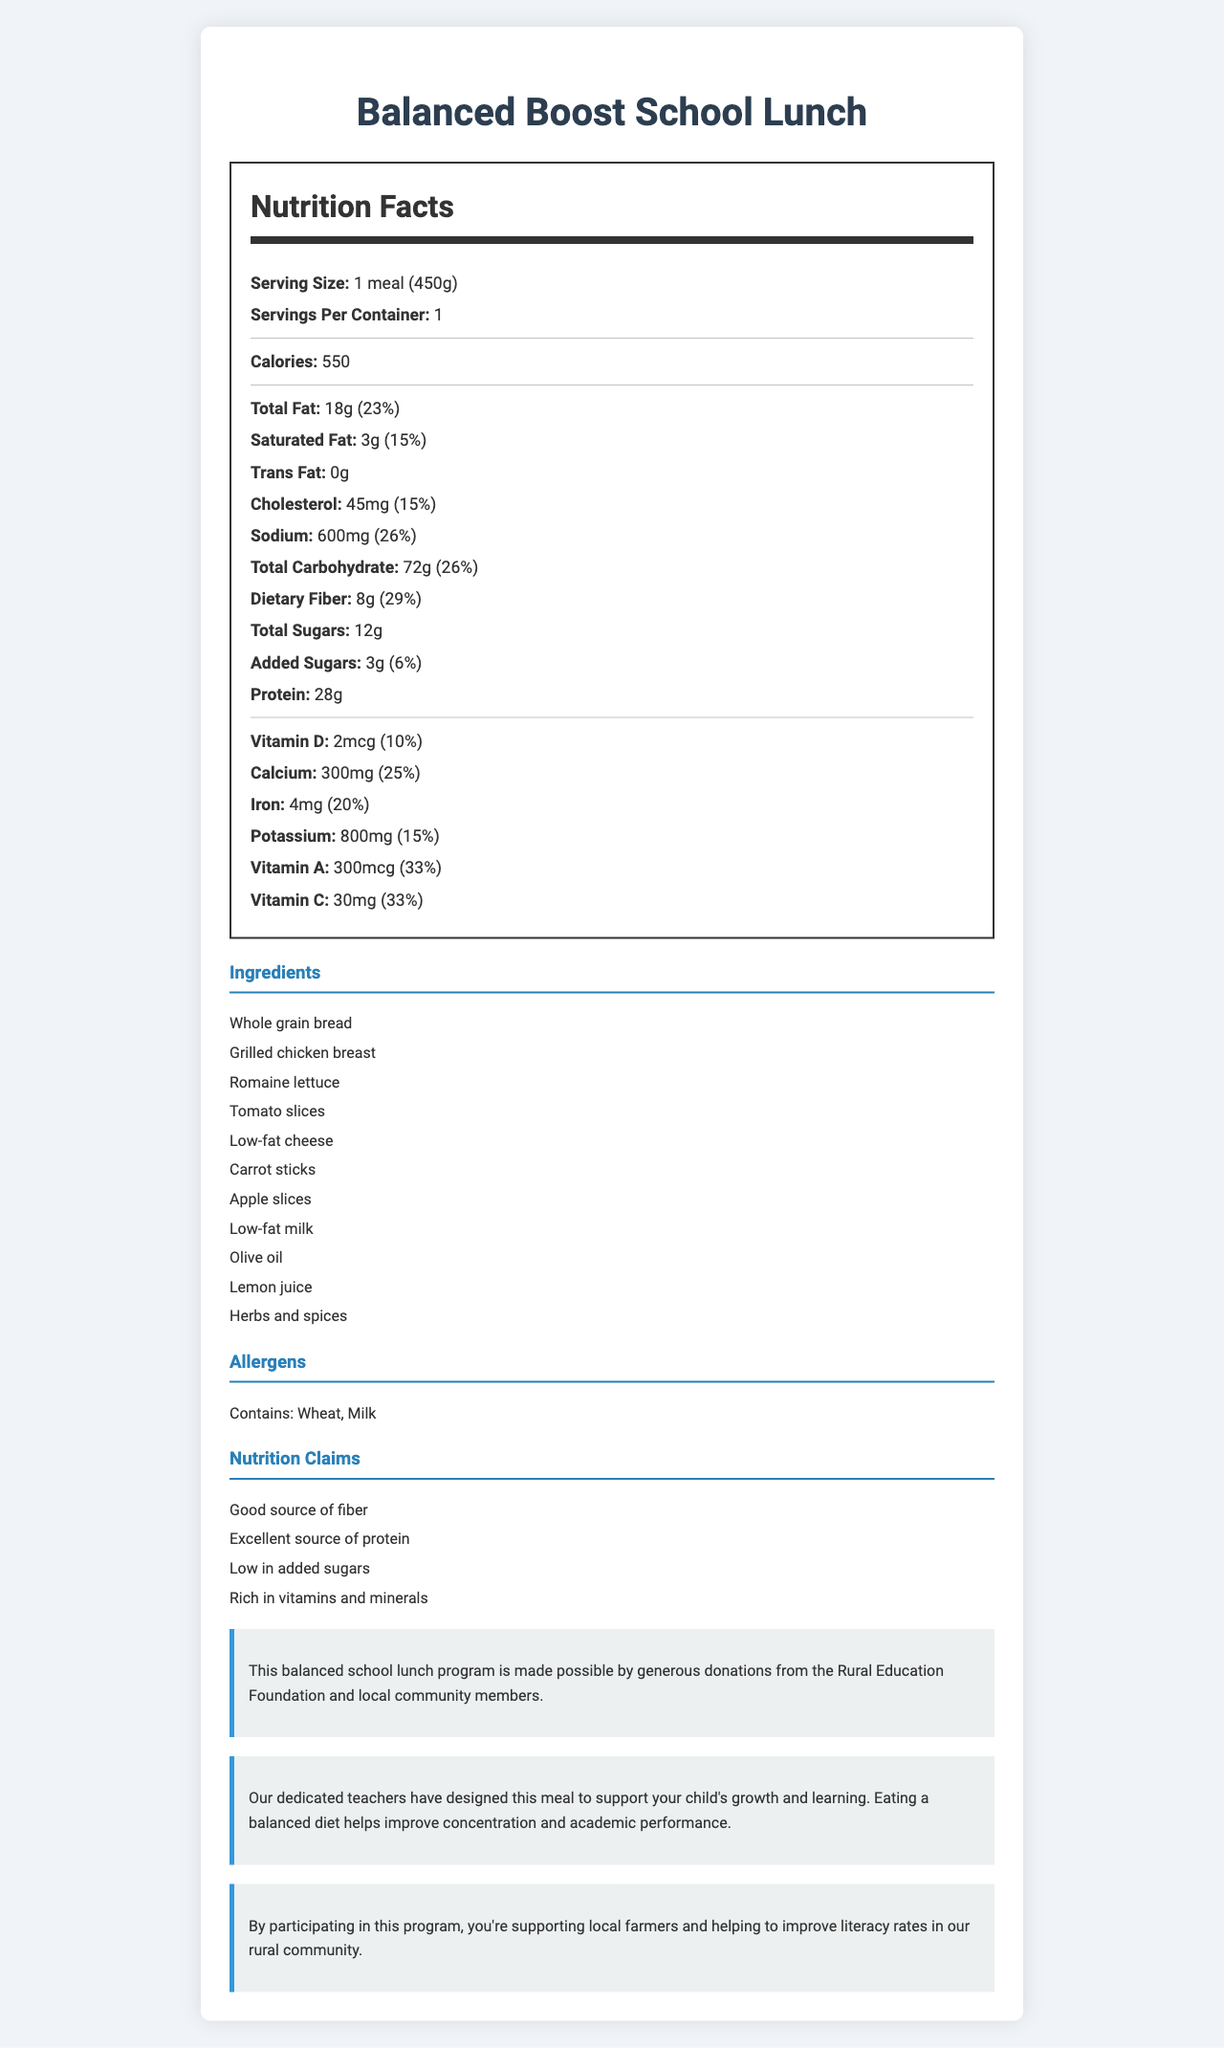what is the name of the product? The product name is clearly stated at the top of the document as "Balanced Boost School Lunch".
Answer: Balanced Boost School Lunch how many calories are in one meal? The document states in the nutrition label section that the meal contains 550 calories.
Answer: 550 calories what is the serving size? The serving size is stated at the beginning of the nutrition label as "1 meal (450g)".
Answer: 1 meal (450g) how much protein is in the meal? The amount of protein is listed in the nutrition label as "28g".
Answer: 28g what allergens are present in this meal? The allergens section lists "Contains: Wheat, Milk".
Answer: Wheat, Milk what is the amount of dietary fiber in the meal? The amount of dietary fiber is provided in the nutrition label as "8g".
Answer: 8g how much vitamin D is in the meal? The amount of Vitamin D is listed in the nutrition facts as "2mcg (10%)".
Answer: 2mcg (10% daily value) what are some of the key ingredients in the meal? A. Grilled chicken breast B. White rice C. Whole grain bread D. Low-fat cheese The ingredients section lists "Whole grain bread", "Grilled chicken breast", and "Low-fat cheese" among others. White rice is not listed.
Answer: A, C, D how much sodium is in one meal? The sodium content is listed as "600mg (26%)" in the nutrition label.
Answer: 600mg (26% daily value) what is the total amount of sugars in the meal? The nutrition label states "Total Sugars: 12g".
Answer: 12g is the meal low in added sugars? The nutrition claims summary states that the meal is "Low in added sugars", and the nutrition facts label lists added sugars as 3g (6% daily value).
Answer: Yes how does the meal support the community? The community impact section explains that the program supports local farmers and helps to improve literacy rates.
Answer: By participating in this program, you're supporting local farmers and helping to improve literacy rates in our rural community. how much calcium is in the meal? The nutrition label states "Calcium: 300mg (25%)".
Answer: 300mg (25% daily value) what is the total fat content in the meal? The nutrition label lists "Total Fat: 18g (23%)".
Answer: 18g (23% daily value) which vitamins are present in the meal? A. Vitamin D B. Vitamin B12 C. Vitamin A D. Vitamin C The vitamins listed in the nutrition label are Vitamin D, Vitamin A, and Vitamin C. Vitamin B12 is not mentioned.
Answer: A, C, D does the meal contain any trans fat? The nutrition label specifies "Trans Fat: 0g", indicating no trans fat.
Answer: No describe the purpose and impact of the Balanced Boost School Lunch program. The educational note explains the purpose as supporting children's growth and learning through a balanced diet, which helps improve concentration and academic performance. The funding source and community impact sections highlight the support from the Rural Education Foundation and local community, while supporting local farmers and improving literacy rates.
Answer: The Balanced Boost School Lunch program provides a nutritious meal designed to support children's growth and learning, funded by donations. It emphasizes balanced nutrition with key nutrients and supports local farmers, while improving literacy rates in the rural community. where are the daily value percentages for vitamins provided? The document does not specify where the daily value percentages for vitamins are sourced from.
Answer: Not enough information 